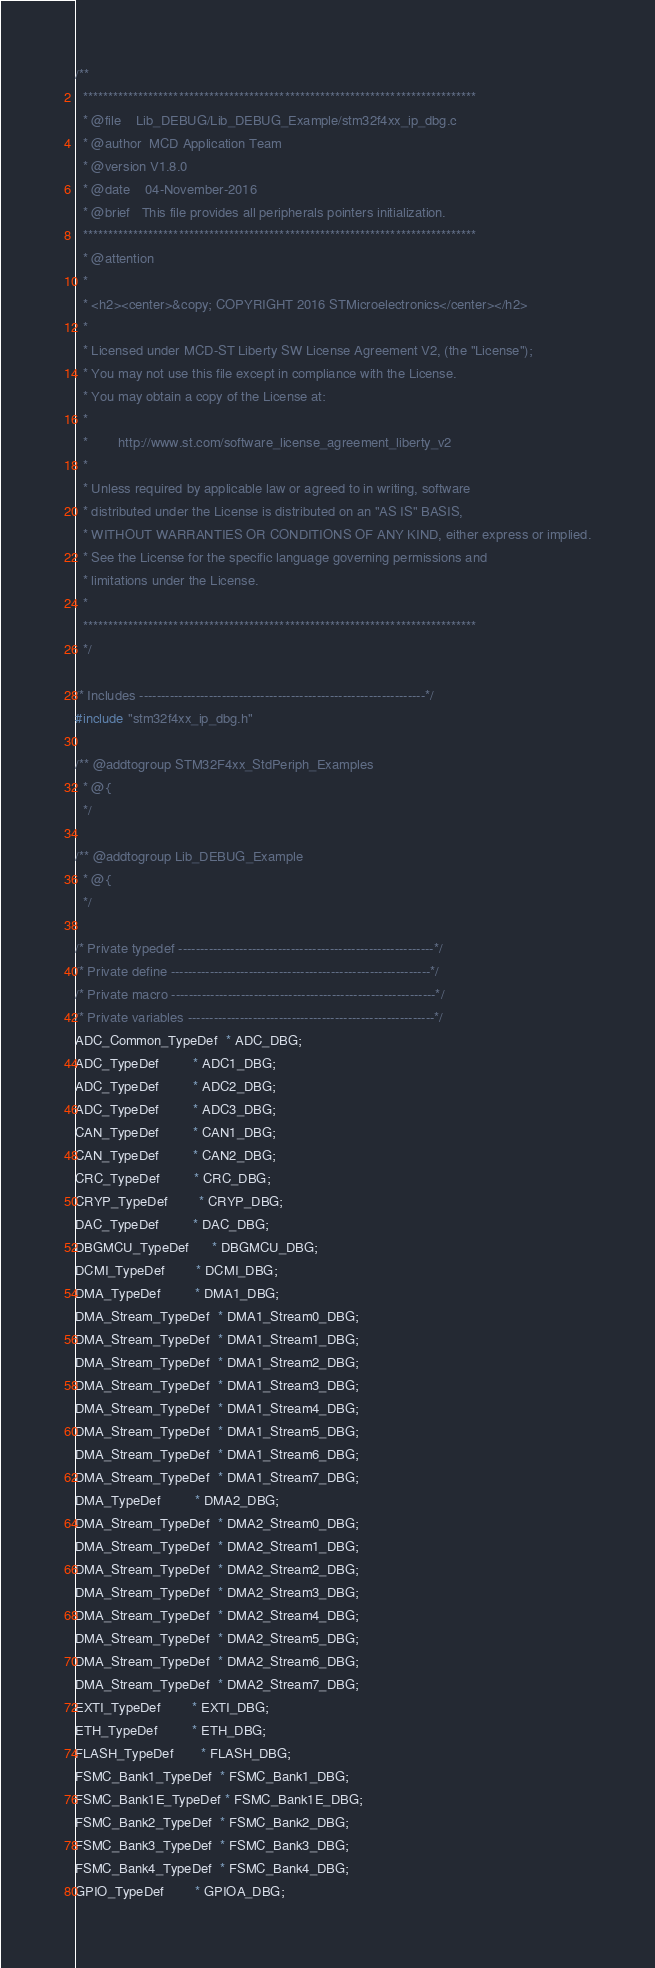<code> <loc_0><loc_0><loc_500><loc_500><_C_>/**
  ******************************************************************************
  * @file    Lib_DEBUG/Lib_DEBUG_Example/stm32f4xx_ip_dbg.c 
  * @author  MCD Application Team
  * @version V1.8.0
  * @date    04-November-2016
  * @brief   This file provides all peripherals pointers initialization.
  ******************************************************************************
  * @attention
  *
  * <h2><center>&copy; COPYRIGHT 2016 STMicroelectronics</center></h2>
  *
  * Licensed under MCD-ST Liberty SW License Agreement V2, (the "License");
  * You may not use this file except in compliance with the License.
  * You may obtain a copy of the License at:
  *
  *        http://www.st.com/software_license_agreement_liberty_v2
  *
  * Unless required by applicable law or agreed to in writing, software 
  * distributed under the License is distributed on an "AS IS" BASIS, 
  * WITHOUT WARRANTIES OR CONDITIONS OF ANY KIND, either express or implied.
  * See the License for the specific language governing permissions and
  * limitations under the License.
  *
  ******************************************************************************
  */

/* Includes ------------------------------------------------------------------*/
#include "stm32f4xx_ip_dbg.h"

/** @addtogroup STM32F4xx_StdPeriph_Examples
  * @{
  */

/** @addtogroup Lib_DEBUG_Example
  * @{
  */ 

/* Private typedef -----------------------------------------------------------*/
/* Private define ------------------------------------------------------------*/
/* Private macro -------------------------------------------------------------*/
/* Private variables ---------------------------------------------------------*/
ADC_Common_TypeDef  * ADC_DBG;
ADC_TypeDef         * ADC1_DBG;
ADC_TypeDef         * ADC2_DBG;
ADC_TypeDef         * ADC3_DBG;
CAN_TypeDef         * CAN1_DBG;
CAN_TypeDef         * CAN2_DBG;
CRC_TypeDef         * CRC_DBG;
CRYP_TypeDef        * CRYP_DBG;
DAC_TypeDef         * DAC_DBG;
DBGMCU_TypeDef      * DBGMCU_DBG;
DCMI_TypeDef        * DCMI_DBG;
DMA_TypeDef         * DMA1_DBG;
DMA_Stream_TypeDef  * DMA1_Stream0_DBG;
DMA_Stream_TypeDef  * DMA1_Stream1_DBG;
DMA_Stream_TypeDef  * DMA1_Stream2_DBG;
DMA_Stream_TypeDef  * DMA1_Stream3_DBG;
DMA_Stream_TypeDef  * DMA1_Stream4_DBG;
DMA_Stream_TypeDef  * DMA1_Stream5_DBG;
DMA_Stream_TypeDef  * DMA1_Stream6_DBG;
DMA_Stream_TypeDef  * DMA1_Stream7_DBG;
DMA_TypeDef         * DMA2_DBG;
DMA_Stream_TypeDef  * DMA2_Stream0_DBG;
DMA_Stream_TypeDef  * DMA2_Stream1_DBG;
DMA_Stream_TypeDef  * DMA2_Stream2_DBG;
DMA_Stream_TypeDef  * DMA2_Stream3_DBG;
DMA_Stream_TypeDef  * DMA2_Stream4_DBG;
DMA_Stream_TypeDef  * DMA2_Stream5_DBG;
DMA_Stream_TypeDef  * DMA2_Stream6_DBG;
DMA_Stream_TypeDef  * DMA2_Stream7_DBG;
EXTI_TypeDef        * EXTI_DBG;
ETH_TypeDef         * ETH_DBG;
FLASH_TypeDef       * FLASH_DBG;
FSMC_Bank1_TypeDef  * FSMC_Bank1_DBG;
FSMC_Bank1E_TypeDef * FSMC_Bank1E_DBG;
FSMC_Bank2_TypeDef  * FSMC_Bank2_DBG;
FSMC_Bank3_TypeDef  * FSMC_Bank3_DBG;
FSMC_Bank4_TypeDef  * FSMC_Bank4_DBG;
GPIO_TypeDef        * GPIOA_DBG;</code> 